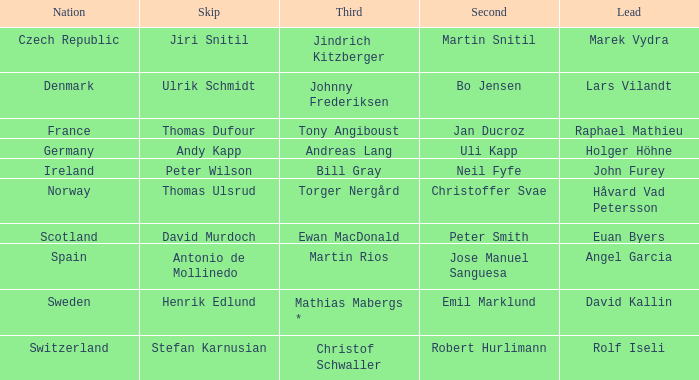Would you be able to parse every entry in this table? {'header': ['Nation', 'Skip', 'Third', 'Second', 'Lead'], 'rows': [['Czech Republic', 'Jiri Snitil', 'Jindrich Kitzberger', 'Martin Snitil', 'Marek Vydra'], ['Denmark', 'Ulrik Schmidt', 'Johnny Frederiksen', 'Bo Jensen', 'Lars Vilandt'], ['France', 'Thomas Dufour', 'Tony Angiboust', 'Jan Ducroz', 'Raphael Mathieu'], ['Germany', 'Andy Kapp', 'Andreas Lang', 'Uli Kapp', 'Holger Höhne'], ['Ireland', 'Peter Wilson', 'Bill Gray', 'Neil Fyfe', 'John Furey'], ['Norway', 'Thomas Ulsrud', 'Torger Nergård', 'Christoffer Svae', 'Håvard Vad Petersson'], ['Scotland', 'David Murdoch', 'Ewan MacDonald', 'Peter Smith', 'Euan Byers'], ['Spain', 'Antonio de Mollinedo', 'Martin Rios', 'Jose Manuel Sanguesa', 'Angel Garcia'], ['Sweden', 'Henrik Edlund', 'Mathias Mabergs *', 'Emil Marklund', 'David Kallin'], ['Switzerland', 'Stefan Karnusian', 'Christof Schwaller', 'Robert Hurlimann', 'Rolf Iseli']]} Which Skip has a Third of tony angiboust? Thomas Dufour. 